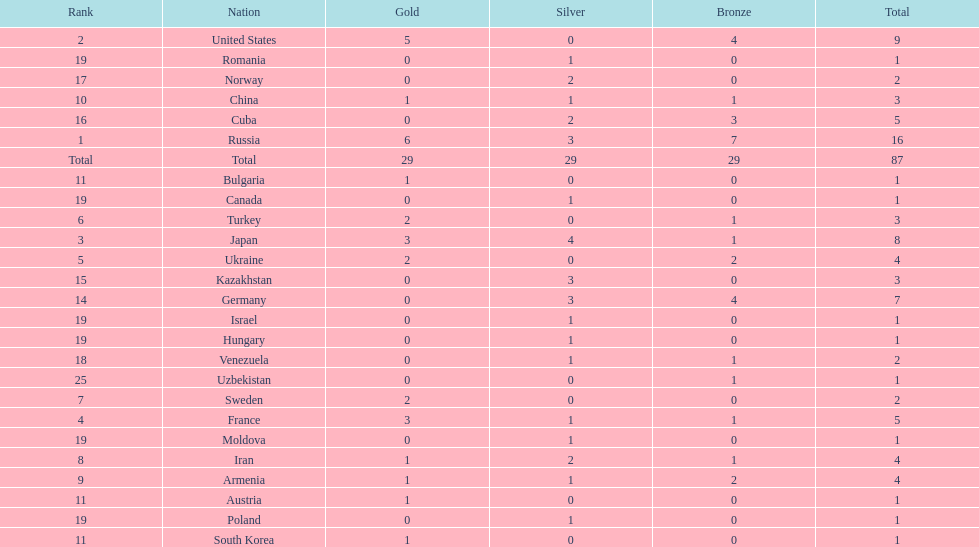Which country won only one medal, a bronze medal? Uzbekistan. 